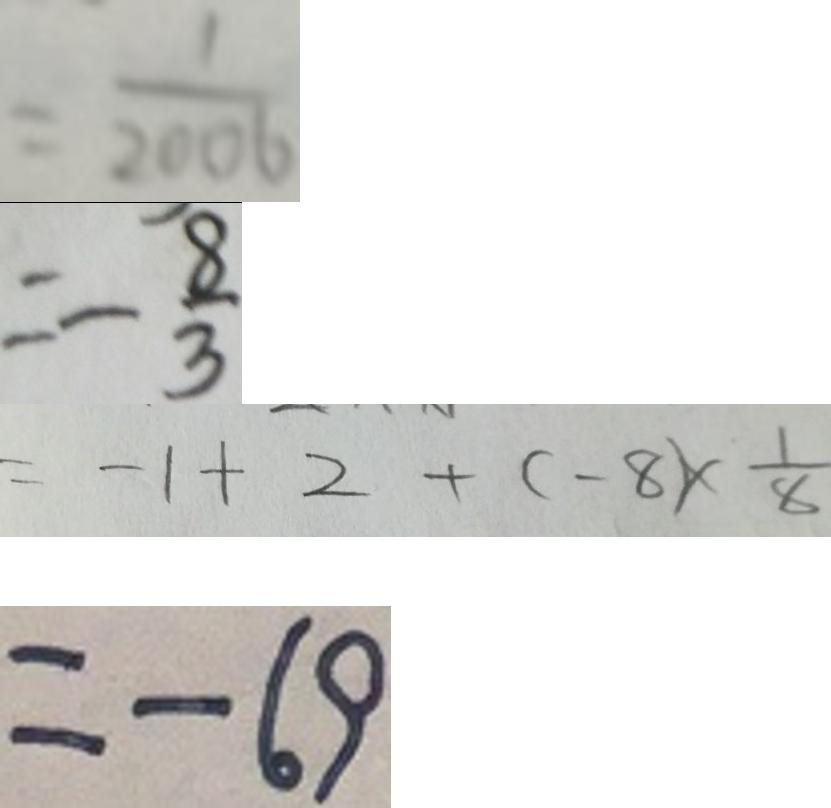Convert formula to latex. <formula><loc_0><loc_0><loc_500><loc_500>= \frac { 1 } { 2 0 0 6 } 
 = - \frac { 8 } { 3 } 
 = - 1 + 2 + ( - 8 ) \times \frac { 1 } { 8 } 
 = - 6 9</formula> 